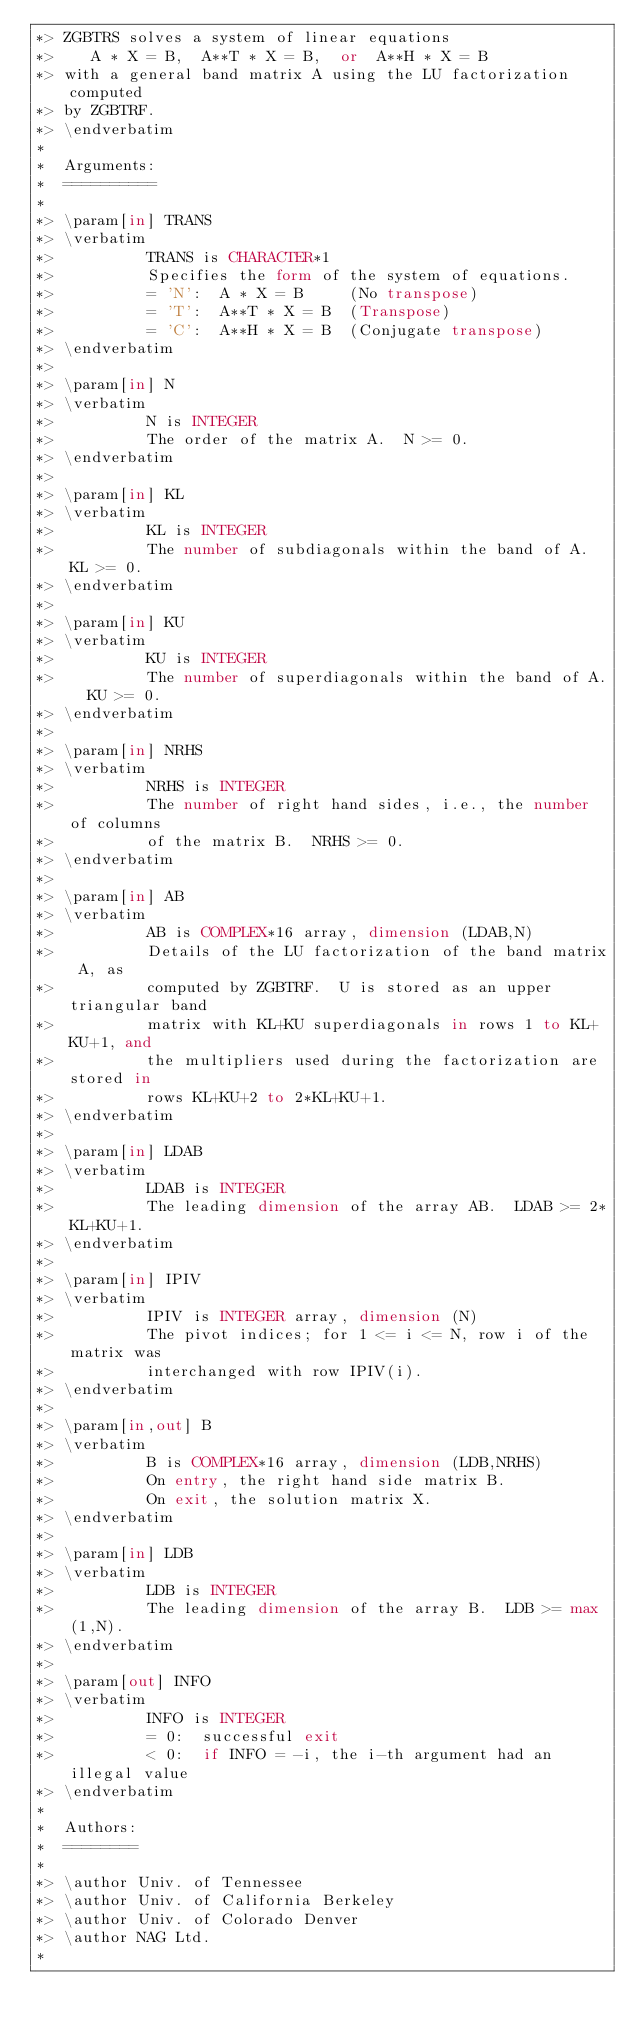<code> <loc_0><loc_0><loc_500><loc_500><_FORTRAN_>*> ZGBTRS solves a system of linear equations
*>    A * X = B,  A**T * X = B,  or  A**H * X = B
*> with a general band matrix A using the LU factorization computed
*> by ZGBTRF.
*> \endverbatim
*
*  Arguments:
*  ==========
*
*> \param[in] TRANS
*> \verbatim
*>          TRANS is CHARACTER*1
*>          Specifies the form of the system of equations.
*>          = 'N':  A * X = B     (No transpose)
*>          = 'T':  A**T * X = B  (Transpose)
*>          = 'C':  A**H * X = B  (Conjugate transpose)
*> \endverbatim
*>
*> \param[in] N
*> \verbatim
*>          N is INTEGER
*>          The order of the matrix A.  N >= 0.
*> \endverbatim
*>
*> \param[in] KL
*> \verbatim
*>          KL is INTEGER
*>          The number of subdiagonals within the band of A.  KL >= 0.
*> \endverbatim
*>
*> \param[in] KU
*> \verbatim
*>          KU is INTEGER
*>          The number of superdiagonals within the band of A.  KU >= 0.
*> \endverbatim
*>
*> \param[in] NRHS
*> \verbatim
*>          NRHS is INTEGER
*>          The number of right hand sides, i.e., the number of columns
*>          of the matrix B.  NRHS >= 0.
*> \endverbatim
*>
*> \param[in] AB
*> \verbatim
*>          AB is COMPLEX*16 array, dimension (LDAB,N)
*>          Details of the LU factorization of the band matrix A, as
*>          computed by ZGBTRF.  U is stored as an upper triangular band
*>          matrix with KL+KU superdiagonals in rows 1 to KL+KU+1, and
*>          the multipliers used during the factorization are stored in
*>          rows KL+KU+2 to 2*KL+KU+1.
*> \endverbatim
*>
*> \param[in] LDAB
*> \verbatim
*>          LDAB is INTEGER
*>          The leading dimension of the array AB.  LDAB >= 2*KL+KU+1.
*> \endverbatim
*>
*> \param[in] IPIV
*> \verbatim
*>          IPIV is INTEGER array, dimension (N)
*>          The pivot indices; for 1 <= i <= N, row i of the matrix was
*>          interchanged with row IPIV(i).
*> \endverbatim
*>
*> \param[in,out] B
*> \verbatim
*>          B is COMPLEX*16 array, dimension (LDB,NRHS)
*>          On entry, the right hand side matrix B.
*>          On exit, the solution matrix X.
*> \endverbatim
*>
*> \param[in] LDB
*> \verbatim
*>          LDB is INTEGER
*>          The leading dimension of the array B.  LDB >= max(1,N).
*> \endverbatim
*>
*> \param[out] INFO
*> \verbatim
*>          INFO is INTEGER
*>          = 0:  successful exit
*>          < 0:  if INFO = -i, the i-th argument had an illegal value
*> \endverbatim
*
*  Authors:
*  ========
*
*> \author Univ. of Tennessee
*> \author Univ. of California Berkeley
*> \author Univ. of Colorado Denver
*> \author NAG Ltd.
*</code> 